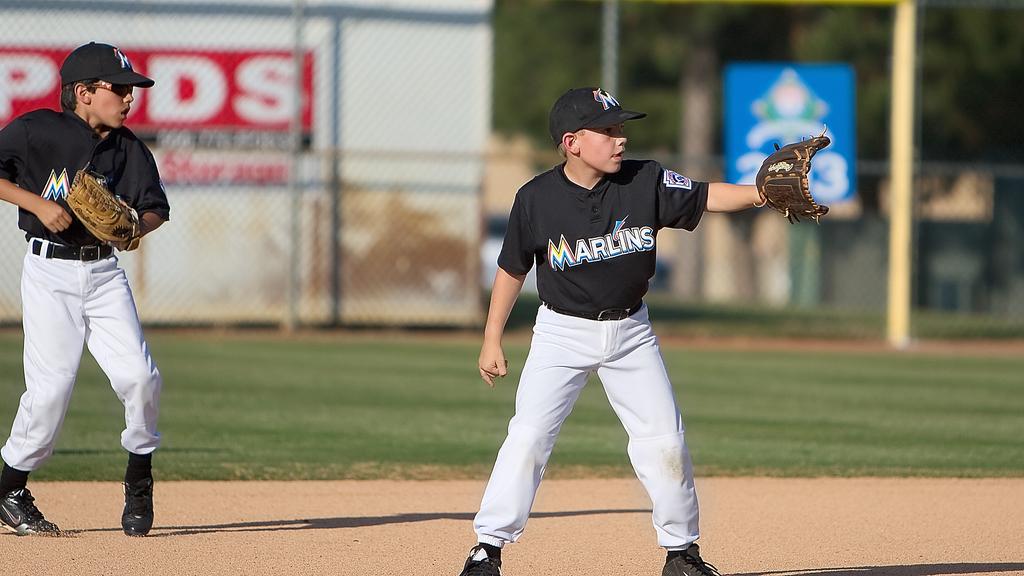What team do these players play for?
Provide a short and direct response. Marlins. Who is the sponsor on the red sign behind the players?
Your response must be concise. Pods. 